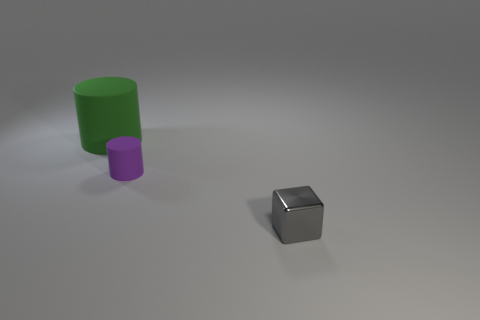Add 3 small green cubes. How many objects exist? 6 Subtract all cylinders. How many objects are left? 1 Subtract all big blocks. Subtract all green matte objects. How many objects are left? 2 Add 1 tiny shiny cubes. How many tiny shiny cubes are left? 2 Add 2 red spheres. How many red spheres exist? 2 Subtract 1 green cylinders. How many objects are left? 2 